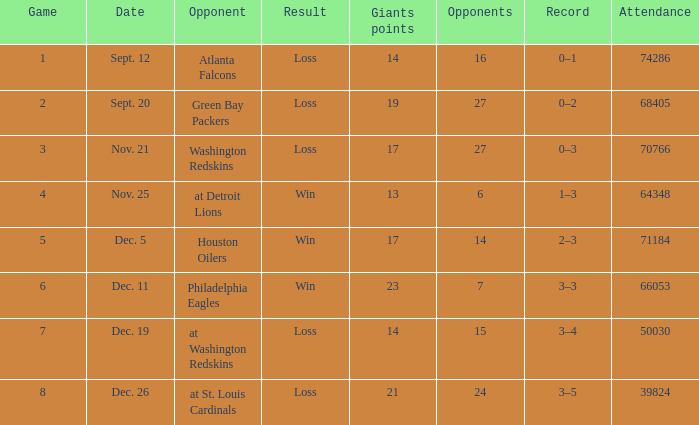What is the record when the opponent is washington redskins? 0–3. 